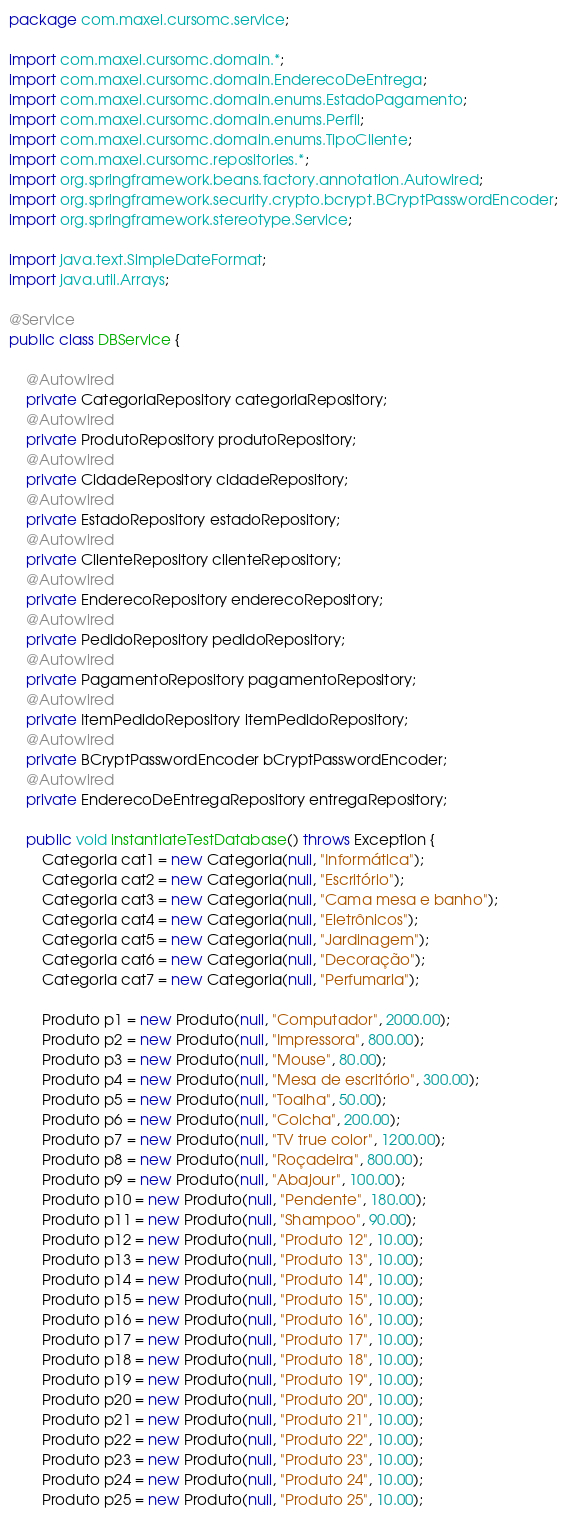<code> <loc_0><loc_0><loc_500><loc_500><_Java_>package com.maxel.cursomc.service;

import com.maxel.cursomc.domain.*;
import com.maxel.cursomc.domain.EnderecoDeEntrega;
import com.maxel.cursomc.domain.enums.EstadoPagamento;
import com.maxel.cursomc.domain.enums.Perfil;
import com.maxel.cursomc.domain.enums.TipoCliente;
import com.maxel.cursomc.repositories.*;
import org.springframework.beans.factory.annotation.Autowired;
import org.springframework.security.crypto.bcrypt.BCryptPasswordEncoder;
import org.springframework.stereotype.Service;

import java.text.SimpleDateFormat;
import java.util.Arrays;

@Service
public class DBService {

    @Autowired
    private CategoriaRepository categoriaRepository;
    @Autowired
    private ProdutoRepository produtoRepository;
    @Autowired
    private CidadeRepository cidadeRepository;
    @Autowired
    private EstadoRepository estadoRepository;
    @Autowired
    private ClienteRepository clienteRepository;
    @Autowired
    private EnderecoRepository enderecoRepository;
    @Autowired
    private PedidoRepository pedidoRepository;
    @Autowired
    private PagamentoRepository pagamentoRepository;
    @Autowired
    private ItemPedidoRepository itemPedidoRepository;
    @Autowired
    private BCryptPasswordEncoder bCryptPasswordEncoder;
    @Autowired
    private EnderecoDeEntregaRepository entregaRepository;

    public void instantiateTestDatabase() throws Exception {
        Categoria cat1 = new Categoria(null, "Informática");
        Categoria cat2 = new Categoria(null, "Escritório");
        Categoria cat3 = new Categoria(null, "Cama mesa e banho");
        Categoria cat4 = new Categoria(null, "Eletrônicos");
        Categoria cat5 = new Categoria(null, "Jardinagem");
        Categoria cat6 = new Categoria(null, "Decoração");
        Categoria cat7 = new Categoria(null, "Perfumaria");

        Produto p1 = new Produto(null, "Computador", 2000.00);
        Produto p2 = new Produto(null, "Impressora", 800.00);
        Produto p3 = new Produto(null, "Mouse", 80.00);
        Produto p4 = new Produto(null, "Mesa de escritório", 300.00);
        Produto p5 = new Produto(null, "Toalha", 50.00);
        Produto p6 = new Produto(null, "Colcha", 200.00);
        Produto p7 = new Produto(null, "TV true color", 1200.00);
        Produto p8 = new Produto(null, "Roçadeira", 800.00);
        Produto p9 = new Produto(null, "Abajour", 100.00);
        Produto p10 = new Produto(null, "Pendente", 180.00);
        Produto p11 = new Produto(null, "Shampoo", 90.00);
        Produto p12 = new Produto(null, "Produto 12", 10.00);
        Produto p13 = new Produto(null, "Produto 13", 10.00);
        Produto p14 = new Produto(null, "Produto 14", 10.00);
        Produto p15 = new Produto(null, "Produto 15", 10.00);
        Produto p16 = new Produto(null, "Produto 16", 10.00);
        Produto p17 = new Produto(null, "Produto 17", 10.00);
        Produto p18 = new Produto(null, "Produto 18", 10.00);
        Produto p19 = new Produto(null, "Produto 19", 10.00);
        Produto p20 = new Produto(null, "Produto 20", 10.00);
        Produto p21 = new Produto(null, "Produto 21", 10.00);
        Produto p22 = new Produto(null, "Produto 22", 10.00);
        Produto p23 = new Produto(null, "Produto 23", 10.00);
        Produto p24 = new Produto(null, "Produto 24", 10.00);
        Produto p25 = new Produto(null, "Produto 25", 10.00);</code> 